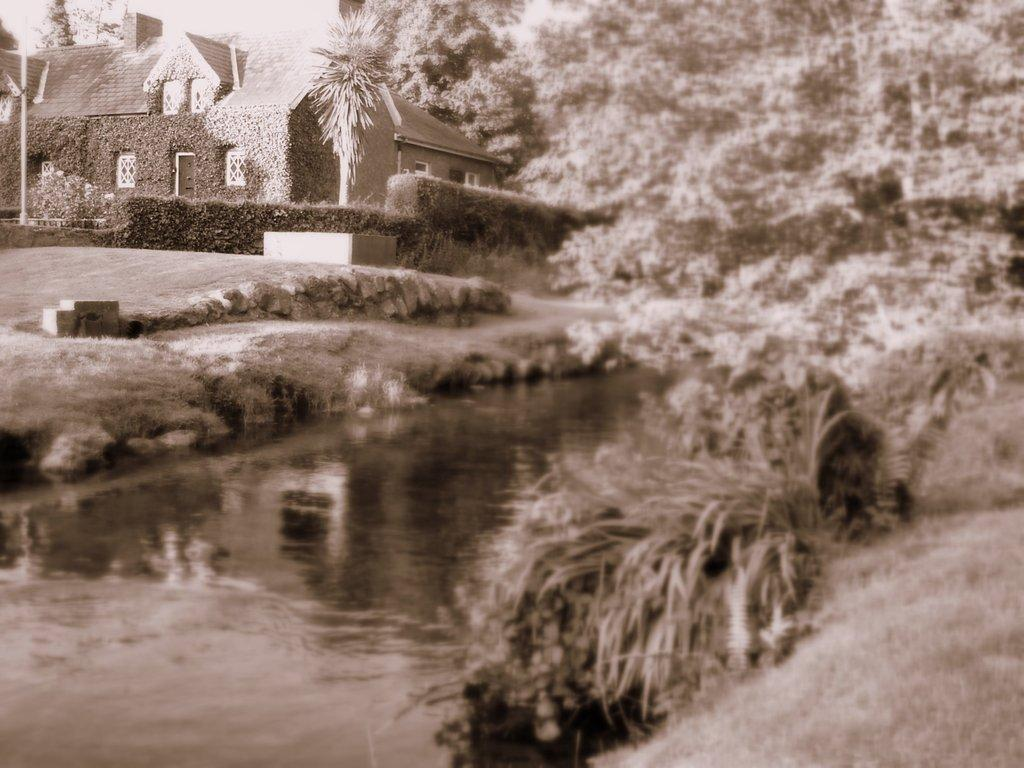What is the color scheme of the image? The image is black and white. What type of structure can be seen in the image? There is a building in the image. What natural elements are present in the image? There are trees and a river at the center of the image. What type of vegetation is visible in the image? There are plants in the image. Can you tell me the punchline of the joke in the image? There is no joke present in the image; it is a black and white image featuring a building, trees, plants, and a river. What type of veil is draped over the river in the image? There is no veil present in the image; it features a river without any additional coverings or decorations. 